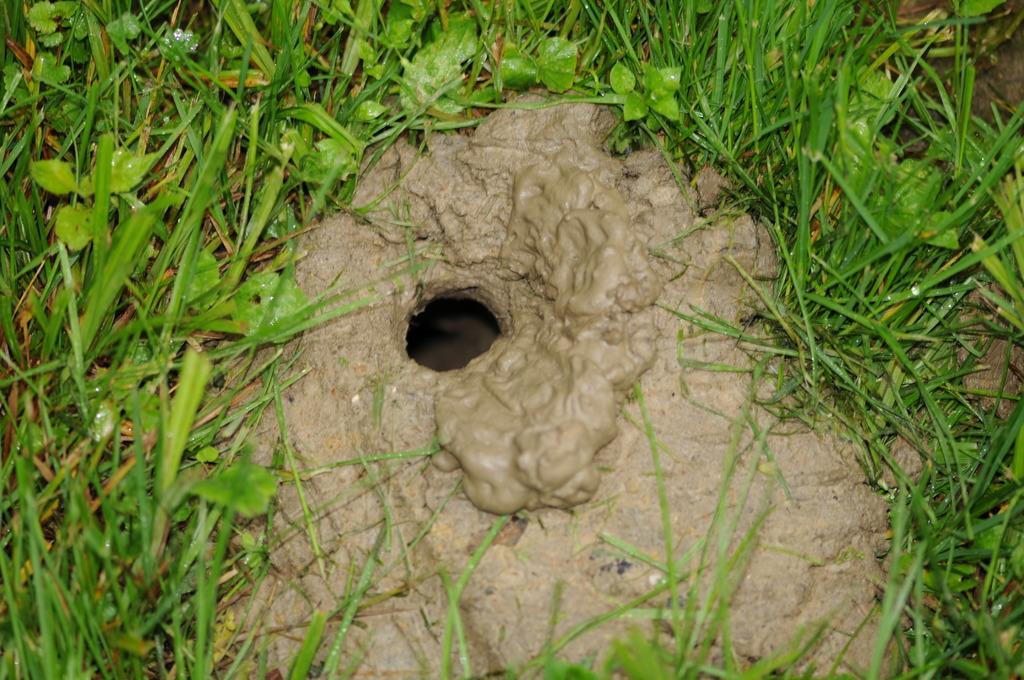Can you describe this image briefly? In front of the image there is a hole in the mud. Around the hole there's grass on the surface. 